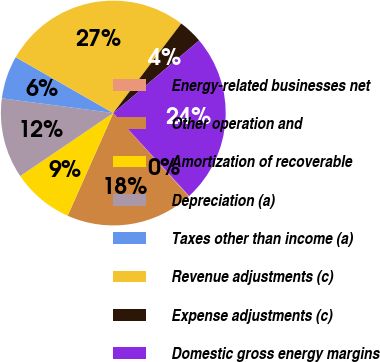Convert chart. <chart><loc_0><loc_0><loc_500><loc_500><pie_chart><fcel>Energy-related businesses net<fcel>Other operation and<fcel>Amortization of recoverable<fcel>Depreciation (a)<fcel>Taxes other than income (a)<fcel>Revenue adjustments (c)<fcel>Expense adjustments (c)<fcel>Domestic gross energy margins<nl><fcel>0.09%<fcel>18.35%<fcel>8.87%<fcel>11.56%<fcel>6.19%<fcel>27.06%<fcel>3.5%<fcel>24.38%<nl></chart> 